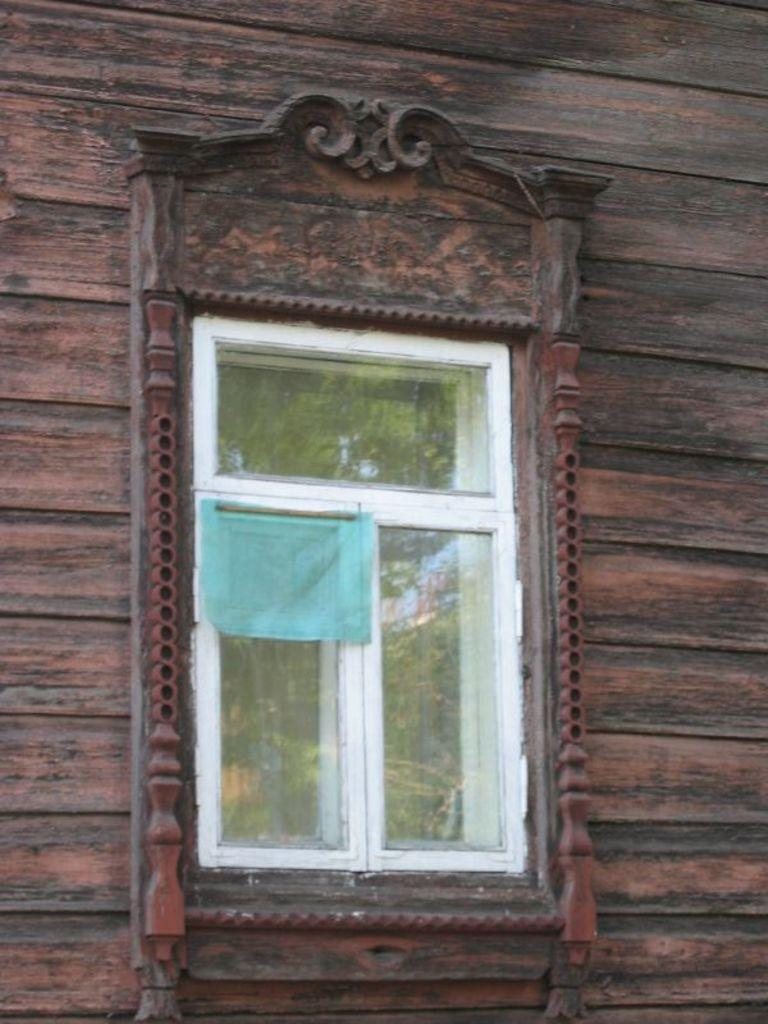What type of structure can be seen in the image? There is a wall in the image. Can you describe any specific features of the wall? The wall has a glass window in it. What type of destruction can be seen on the wall in the image? There is no destruction visible on the wall in the image. What type of mineral can be seen in the wall in the image? The image does not show any minerals, including quartz, in the wall. What type of teeth can be seen in the wall in the image? There are no teeth present in the wall in the image. 